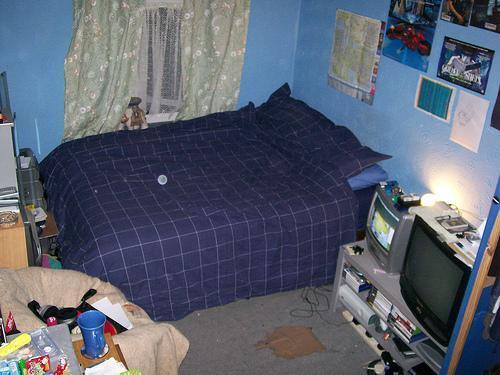How many televisions are there?
Give a very brief answer. 2. How many electronic devices appear to be turned on?
Give a very brief answer. 1. 